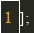Convert code to text. <code><loc_0><loc_0><loc_500><loc_500><_JavaScript_>];</code> 